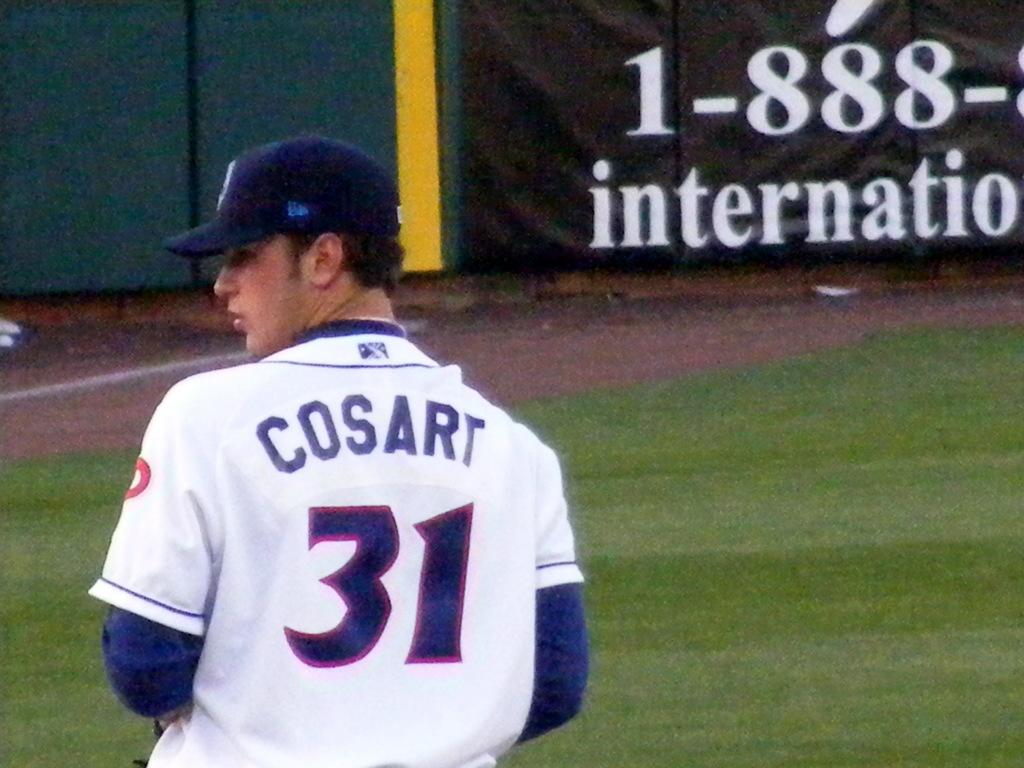<image>
Provide a brief description of the given image. Baseball player Cosart, number 31 stands near the foul line. 